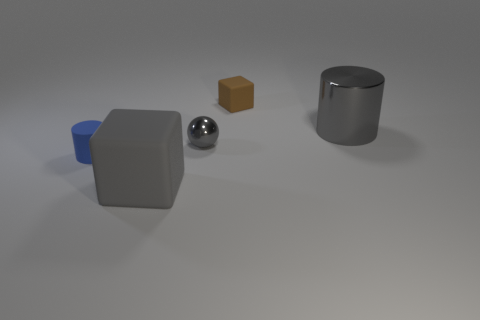Add 2 gray matte blocks. How many objects exist? 7 Subtract all cubes. How many objects are left? 3 Subtract 0 cyan cubes. How many objects are left? 5 Subtract all tiny blue matte cylinders. Subtract all matte cylinders. How many objects are left? 3 Add 2 brown objects. How many brown objects are left? 3 Add 1 brown metal cylinders. How many brown metal cylinders exist? 1 